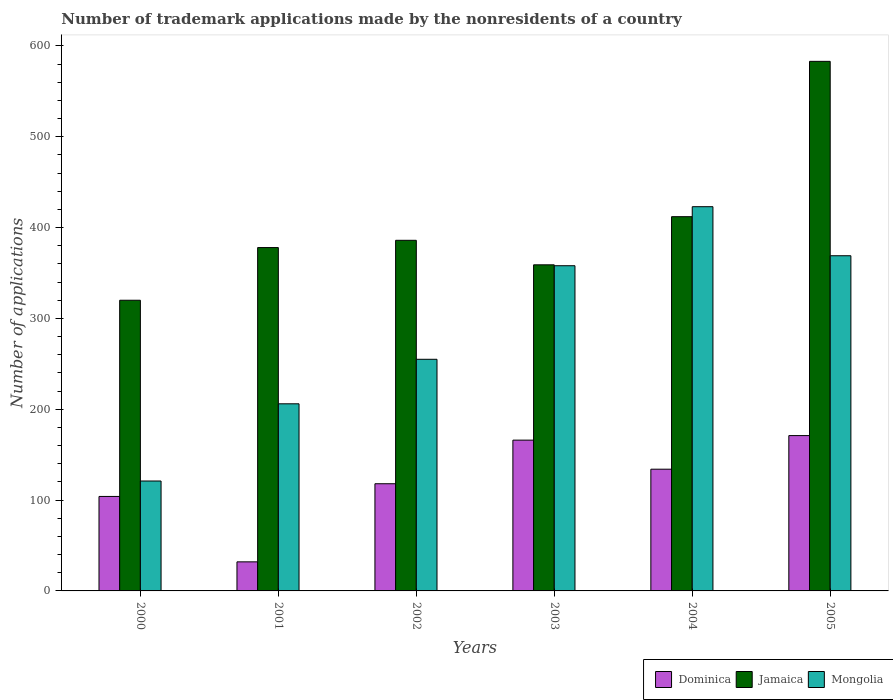How many different coloured bars are there?
Your answer should be very brief. 3. How many groups of bars are there?
Keep it short and to the point. 6. Are the number of bars per tick equal to the number of legend labels?
Your answer should be very brief. Yes. What is the label of the 2nd group of bars from the left?
Provide a short and direct response. 2001. In how many cases, is the number of bars for a given year not equal to the number of legend labels?
Ensure brevity in your answer.  0. Across all years, what is the maximum number of trademark applications made by the nonresidents in Dominica?
Give a very brief answer. 171. Across all years, what is the minimum number of trademark applications made by the nonresidents in Jamaica?
Offer a terse response. 320. In which year was the number of trademark applications made by the nonresidents in Mongolia maximum?
Offer a terse response. 2004. What is the total number of trademark applications made by the nonresidents in Mongolia in the graph?
Your answer should be compact. 1732. What is the difference between the number of trademark applications made by the nonresidents in Jamaica in 2003 and that in 2004?
Ensure brevity in your answer.  -53. What is the difference between the number of trademark applications made by the nonresidents in Jamaica in 2000 and the number of trademark applications made by the nonresidents in Mongolia in 2001?
Provide a succinct answer. 114. What is the average number of trademark applications made by the nonresidents in Jamaica per year?
Provide a succinct answer. 406.33. In the year 2002, what is the difference between the number of trademark applications made by the nonresidents in Dominica and number of trademark applications made by the nonresidents in Mongolia?
Your answer should be very brief. -137. What is the ratio of the number of trademark applications made by the nonresidents in Jamaica in 2002 to that in 2004?
Your response must be concise. 0.94. Is the difference between the number of trademark applications made by the nonresidents in Dominica in 2000 and 2004 greater than the difference between the number of trademark applications made by the nonresidents in Mongolia in 2000 and 2004?
Make the answer very short. Yes. What is the difference between the highest and the second highest number of trademark applications made by the nonresidents in Dominica?
Ensure brevity in your answer.  5. What is the difference between the highest and the lowest number of trademark applications made by the nonresidents in Mongolia?
Give a very brief answer. 302. Is the sum of the number of trademark applications made by the nonresidents in Jamaica in 2000 and 2003 greater than the maximum number of trademark applications made by the nonresidents in Dominica across all years?
Offer a very short reply. Yes. What does the 2nd bar from the left in 2005 represents?
Your response must be concise. Jamaica. What does the 3rd bar from the right in 2001 represents?
Provide a short and direct response. Dominica. Is it the case that in every year, the sum of the number of trademark applications made by the nonresidents in Jamaica and number of trademark applications made by the nonresidents in Dominica is greater than the number of trademark applications made by the nonresidents in Mongolia?
Your answer should be compact. Yes. How many bars are there?
Keep it short and to the point. 18. How many years are there in the graph?
Your answer should be compact. 6. What is the difference between two consecutive major ticks on the Y-axis?
Give a very brief answer. 100. Does the graph contain any zero values?
Your answer should be very brief. No. Does the graph contain grids?
Ensure brevity in your answer.  No. Where does the legend appear in the graph?
Offer a very short reply. Bottom right. How many legend labels are there?
Your response must be concise. 3. How are the legend labels stacked?
Keep it short and to the point. Horizontal. What is the title of the graph?
Your answer should be compact. Number of trademark applications made by the nonresidents of a country. What is the label or title of the Y-axis?
Offer a very short reply. Number of applications. What is the Number of applications of Dominica in 2000?
Provide a succinct answer. 104. What is the Number of applications of Jamaica in 2000?
Give a very brief answer. 320. What is the Number of applications of Mongolia in 2000?
Your answer should be very brief. 121. What is the Number of applications of Dominica in 2001?
Keep it short and to the point. 32. What is the Number of applications in Jamaica in 2001?
Give a very brief answer. 378. What is the Number of applications in Mongolia in 2001?
Ensure brevity in your answer.  206. What is the Number of applications in Dominica in 2002?
Provide a short and direct response. 118. What is the Number of applications in Jamaica in 2002?
Ensure brevity in your answer.  386. What is the Number of applications of Mongolia in 2002?
Ensure brevity in your answer.  255. What is the Number of applications in Dominica in 2003?
Offer a very short reply. 166. What is the Number of applications of Jamaica in 2003?
Provide a succinct answer. 359. What is the Number of applications in Mongolia in 2003?
Your response must be concise. 358. What is the Number of applications in Dominica in 2004?
Provide a short and direct response. 134. What is the Number of applications in Jamaica in 2004?
Your answer should be very brief. 412. What is the Number of applications of Mongolia in 2004?
Your answer should be very brief. 423. What is the Number of applications of Dominica in 2005?
Give a very brief answer. 171. What is the Number of applications of Jamaica in 2005?
Make the answer very short. 583. What is the Number of applications in Mongolia in 2005?
Keep it short and to the point. 369. Across all years, what is the maximum Number of applications in Dominica?
Give a very brief answer. 171. Across all years, what is the maximum Number of applications in Jamaica?
Provide a short and direct response. 583. Across all years, what is the maximum Number of applications of Mongolia?
Keep it short and to the point. 423. Across all years, what is the minimum Number of applications of Jamaica?
Ensure brevity in your answer.  320. Across all years, what is the minimum Number of applications in Mongolia?
Make the answer very short. 121. What is the total Number of applications in Dominica in the graph?
Provide a short and direct response. 725. What is the total Number of applications of Jamaica in the graph?
Offer a very short reply. 2438. What is the total Number of applications of Mongolia in the graph?
Keep it short and to the point. 1732. What is the difference between the Number of applications of Jamaica in 2000 and that in 2001?
Provide a short and direct response. -58. What is the difference between the Number of applications of Mongolia in 2000 and that in 2001?
Make the answer very short. -85. What is the difference between the Number of applications in Jamaica in 2000 and that in 2002?
Provide a succinct answer. -66. What is the difference between the Number of applications in Mongolia in 2000 and that in 2002?
Offer a terse response. -134. What is the difference between the Number of applications of Dominica in 2000 and that in 2003?
Ensure brevity in your answer.  -62. What is the difference between the Number of applications of Jamaica in 2000 and that in 2003?
Your response must be concise. -39. What is the difference between the Number of applications in Mongolia in 2000 and that in 2003?
Make the answer very short. -237. What is the difference between the Number of applications in Jamaica in 2000 and that in 2004?
Keep it short and to the point. -92. What is the difference between the Number of applications of Mongolia in 2000 and that in 2004?
Keep it short and to the point. -302. What is the difference between the Number of applications of Dominica in 2000 and that in 2005?
Ensure brevity in your answer.  -67. What is the difference between the Number of applications in Jamaica in 2000 and that in 2005?
Your answer should be very brief. -263. What is the difference between the Number of applications in Mongolia in 2000 and that in 2005?
Your answer should be very brief. -248. What is the difference between the Number of applications of Dominica in 2001 and that in 2002?
Provide a short and direct response. -86. What is the difference between the Number of applications of Jamaica in 2001 and that in 2002?
Offer a very short reply. -8. What is the difference between the Number of applications in Mongolia in 2001 and that in 2002?
Provide a short and direct response. -49. What is the difference between the Number of applications of Dominica in 2001 and that in 2003?
Provide a short and direct response. -134. What is the difference between the Number of applications in Mongolia in 2001 and that in 2003?
Offer a very short reply. -152. What is the difference between the Number of applications in Dominica in 2001 and that in 2004?
Provide a succinct answer. -102. What is the difference between the Number of applications in Jamaica in 2001 and that in 2004?
Provide a short and direct response. -34. What is the difference between the Number of applications in Mongolia in 2001 and that in 2004?
Your answer should be compact. -217. What is the difference between the Number of applications of Dominica in 2001 and that in 2005?
Make the answer very short. -139. What is the difference between the Number of applications in Jamaica in 2001 and that in 2005?
Ensure brevity in your answer.  -205. What is the difference between the Number of applications of Mongolia in 2001 and that in 2005?
Your answer should be very brief. -163. What is the difference between the Number of applications in Dominica in 2002 and that in 2003?
Give a very brief answer. -48. What is the difference between the Number of applications in Jamaica in 2002 and that in 2003?
Your response must be concise. 27. What is the difference between the Number of applications of Mongolia in 2002 and that in 2003?
Provide a succinct answer. -103. What is the difference between the Number of applications of Dominica in 2002 and that in 2004?
Give a very brief answer. -16. What is the difference between the Number of applications of Jamaica in 2002 and that in 2004?
Offer a terse response. -26. What is the difference between the Number of applications of Mongolia in 2002 and that in 2004?
Offer a terse response. -168. What is the difference between the Number of applications in Dominica in 2002 and that in 2005?
Your answer should be very brief. -53. What is the difference between the Number of applications in Jamaica in 2002 and that in 2005?
Keep it short and to the point. -197. What is the difference between the Number of applications of Mongolia in 2002 and that in 2005?
Ensure brevity in your answer.  -114. What is the difference between the Number of applications in Dominica in 2003 and that in 2004?
Your response must be concise. 32. What is the difference between the Number of applications of Jamaica in 2003 and that in 2004?
Your answer should be compact. -53. What is the difference between the Number of applications in Mongolia in 2003 and that in 2004?
Provide a short and direct response. -65. What is the difference between the Number of applications in Dominica in 2003 and that in 2005?
Your answer should be compact. -5. What is the difference between the Number of applications in Jamaica in 2003 and that in 2005?
Provide a succinct answer. -224. What is the difference between the Number of applications of Dominica in 2004 and that in 2005?
Your response must be concise. -37. What is the difference between the Number of applications of Jamaica in 2004 and that in 2005?
Keep it short and to the point. -171. What is the difference between the Number of applications of Dominica in 2000 and the Number of applications of Jamaica in 2001?
Give a very brief answer. -274. What is the difference between the Number of applications in Dominica in 2000 and the Number of applications in Mongolia in 2001?
Make the answer very short. -102. What is the difference between the Number of applications of Jamaica in 2000 and the Number of applications of Mongolia in 2001?
Make the answer very short. 114. What is the difference between the Number of applications of Dominica in 2000 and the Number of applications of Jamaica in 2002?
Provide a succinct answer. -282. What is the difference between the Number of applications in Dominica in 2000 and the Number of applications in Mongolia in 2002?
Offer a terse response. -151. What is the difference between the Number of applications of Jamaica in 2000 and the Number of applications of Mongolia in 2002?
Provide a short and direct response. 65. What is the difference between the Number of applications in Dominica in 2000 and the Number of applications in Jamaica in 2003?
Keep it short and to the point. -255. What is the difference between the Number of applications in Dominica in 2000 and the Number of applications in Mongolia in 2003?
Offer a terse response. -254. What is the difference between the Number of applications in Jamaica in 2000 and the Number of applications in Mongolia in 2003?
Your response must be concise. -38. What is the difference between the Number of applications of Dominica in 2000 and the Number of applications of Jamaica in 2004?
Give a very brief answer. -308. What is the difference between the Number of applications of Dominica in 2000 and the Number of applications of Mongolia in 2004?
Keep it short and to the point. -319. What is the difference between the Number of applications in Jamaica in 2000 and the Number of applications in Mongolia in 2004?
Your response must be concise. -103. What is the difference between the Number of applications in Dominica in 2000 and the Number of applications in Jamaica in 2005?
Offer a very short reply. -479. What is the difference between the Number of applications of Dominica in 2000 and the Number of applications of Mongolia in 2005?
Make the answer very short. -265. What is the difference between the Number of applications of Jamaica in 2000 and the Number of applications of Mongolia in 2005?
Offer a terse response. -49. What is the difference between the Number of applications of Dominica in 2001 and the Number of applications of Jamaica in 2002?
Give a very brief answer. -354. What is the difference between the Number of applications of Dominica in 2001 and the Number of applications of Mongolia in 2002?
Make the answer very short. -223. What is the difference between the Number of applications of Jamaica in 2001 and the Number of applications of Mongolia in 2002?
Your answer should be very brief. 123. What is the difference between the Number of applications in Dominica in 2001 and the Number of applications in Jamaica in 2003?
Ensure brevity in your answer.  -327. What is the difference between the Number of applications in Dominica in 2001 and the Number of applications in Mongolia in 2003?
Your answer should be compact. -326. What is the difference between the Number of applications of Dominica in 2001 and the Number of applications of Jamaica in 2004?
Your answer should be compact. -380. What is the difference between the Number of applications of Dominica in 2001 and the Number of applications of Mongolia in 2004?
Ensure brevity in your answer.  -391. What is the difference between the Number of applications of Jamaica in 2001 and the Number of applications of Mongolia in 2004?
Your answer should be compact. -45. What is the difference between the Number of applications in Dominica in 2001 and the Number of applications in Jamaica in 2005?
Offer a terse response. -551. What is the difference between the Number of applications of Dominica in 2001 and the Number of applications of Mongolia in 2005?
Provide a short and direct response. -337. What is the difference between the Number of applications of Dominica in 2002 and the Number of applications of Jamaica in 2003?
Give a very brief answer. -241. What is the difference between the Number of applications of Dominica in 2002 and the Number of applications of Mongolia in 2003?
Provide a succinct answer. -240. What is the difference between the Number of applications in Dominica in 2002 and the Number of applications in Jamaica in 2004?
Offer a very short reply. -294. What is the difference between the Number of applications of Dominica in 2002 and the Number of applications of Mongolia in 2004?
Your response must be concise. -305. What is the difference between the Number of applications in Jamaica in 2002 and the Number of applications in Mongolia in 2004?
Make the answer very short. -37. What is the difference between the Number of applications of Dominica in 2002 and the Number of applications of Jamaica in 2005?
Make the answer very short. -465. What is the difference between the Number of applications in Dominica in 2002 and the Number of applications in Mongolia in 2005?
Give a very brief answer. -251. What is the difference between the Number of applications of Jamaica in 2002 and the Number of applications of Mongolia in 2005?
Provide a short and direct response. 17. What is the difference between the Number of applications of Dominica in 2003 and the Number of applications of Jamaica in 2004?
Offer a terse response. -246. What is the difference between the Number of applications of Dominica in 2003 and the Number of applications of Mongolia in 2004?
Ensure brevity in your answer.  -257. What is the difference between the Number of applications of Jamaica in 2003 and the Number of applications of Mongolia in 2004?
Your response must be concise. -64. What is the difference between the Number of applications of Dominica in 2003 and the Number of applications of Jamaica in 2005?
Offer a very short reply. -417. What is the difference between the Number of applications of Dominica in 2003 and the Number of applications of Mongolia in 2005?
Ensure brevity in your answer.  -203. What is the difference between the Number of applications in Jamaica in 2003 and the Number of applications in Mongolia in 2005?
Ensure brevity in your answer.  -10. What is the difference between the Number of applications of Dominica in 2004 and the Number of applications of Jamaica in 2005?
Make the answer very short. -449. What is the difference between the Number of applications in Dominica in 2004 and the Number of applications in Mongolia in 2005?
Ensure brevity in your answer.  -235. What is the average Number of applications in Dominica per year?
Make the answer very short. 120.83. What is the average Number of applications of Jamaica per year?
Give a very brief answer. 406.33. What is the average Number of applications of Mongolia per year?
Offer a very short reply. 288.67. In the year 2000, what is the difference between the Number of applications of Dominica and Number of applications of Jamaica?
Your response must be concise. -216. In the year 2000, what is the difference between the Number of applications of Dominica and Number of applications of Mongolia?
Offer a very short reply. -17. In the year 2000, what is the difference between the Number of applications of Jamaica and Number of applications of Mongolia?
Your answer should be very brief. 199. In the year 2001, what is the difference between the Number of applications of Dominica and Number of applications of Jamaica?
Keep it short and to the point. -346. In the year 2001, what is the difference between the Number of applications of Dominica and Number of applications of Mongolia?
Provide a short and direct response. -174. In the year 2001, what is the difference between the Number of applications of Jamaica and Number of applications of Mongolia?
Keep it short and to the point. 172. In the year 2002, what is the difference between the Number of applications of Dominica and Number of applications of Jamaica?
Your answer should be very brief. -268. In the year 2002, what is the difference between the Number of applications in Dominica and Number of applications in Mongolia?
Provide a succinct answer. -137. In the year 2002, what is the difference between the Number of applications of Jamaica and Number of applications of Mongolia?
Make the answer very short. 131. In the year 2003, what is the difference between the Number of applications in Dominica and Number of applications in Jamaica?
Give a very brief answer. -193. In the year 2003, what is the difference between the Number of applications in Dominica and Number of applications in Mongolia?
Offer a very short reply. -192. In the year 2003, what is the difference between the Number of applications in Jamaica and Number of applications in Mongolia?
Provide a succinct answer. 1. In the year 2004, what is the difference between the Number of applications in Dominica and Number of applications in Jamaica?
Your answer should be very brief. -278. In the year 2004, what is the difference between the Number of applications of Dominica and Number of applications of Mongolia?
Give a very brief answer. -289. In the year 2004, what is the difference between the Number of applications of Jamaica and Number of applications of Mongolia?
Give a very brief answer. -11. In the year 2005, what is the difference between the Number of applications in Dominica and Number of applications in Jamaica?
Keep it short and to the point. -412. In the year 2005, what is the difference between the Number of applications of Dominica and Number of applications of Mongolia?
Your answer should be very brief. -198. In the year 2005, what is the difference between the Number of applications in Jamaica and Number of applications in Mongolia?
Make the answer very short. 214. What is the ratio of the Number of applications of Dominica in 2000 to that in 2001?
Provide a succinct answer. 3.25. What is the ratio of the Number of applications in Jamaica in 2000 to that in 2001?
Your answer should be very brief. 0.85. What is the ratio of the Number of applications of Mongolia in 2000 to that in 2001?
Your response must be concise. 0.59. What is the ratio of the Number of applications in Dominica in 2000 to that in 2002?
Make the answer very short. 0.88. What is the ratio of the Number of applications of Jamaica in 2000 to that in 2002?
Keep it short and to the point. 0.83. What is the ratio of the Number of applications of Mongolia in 2000 to that in 2002?
Provide a succinct answer. 0.47. What is the ratio of the Number of applications in Dominica in 2000 to that in 2003?
Keep it short and to the point. 0.63. What is the ratio of the Number of applications of Jamaica in 2000 to that in 2003?
Offer a very short reply. 0.89. What is the ratio of the Number of applications of Mongolia in 2000 to that in 2003?
Give a very brief answer. 0.34. What is the ratio of the Number of applications of Dominica in 2000 to that in 2004?
Provide a succinct answer. 0.78. What is the ratio of the Number of applications in Jamaica in 2000 to that in 2004?
Ensure brevity in your answer.  0.78. What is the ratio of the Number of applications of Mongolia in 2000 to that in 2004?
Your response must be concise. 0.29. What is the ratio of the Number of applications of Dominica in 2000 to that in 2005?
Your answer should be very brief. 0.61. What is the ratio of the Number of applications in Jamaica in 2000 to that in 2005?
Your response must be concise. 0.55. What is the ratio of the Number of applications of Mongolia in 2000 to that in 2005?
Ensure brevity in your answer.  0.33. What is the ratio of the Number of applications of Dominica in 2001 to that in 2002?
Provide a short and direct response. 0.27. What is the ratio of the Number of applications in Jamaica in 2001 to that in 2002?
Your answer should be very brief. 0.98. What is the ratio of the Number of applications of Mongolia in 2001 to that in 2002?
Your response must be concise. 0.81. What is the ratio of the Number of applications in Dominica in 2001 to that in 2003?
Make the answer very short. 0.19. What is the ratio of the Number of applications in Jamaica in 2001 to that in 2003?
Keep it short and to the point. 1.05. What is the ratio of the Number of applications of Mongolia in 2001 to that in 2003?
Give a very brief answer. 0.58. What is the ratio of the Number of applications in Dominica in 2001 to that in 2004?
Ensure brevity in your answer.  0.24. What is the ratio of the Number of applications in Jamaica in 2001 to that in 2004?
Your answer should be very brief. 0.92. What is the ratio of the Number of applications of Mongolia in 2001 to that in 2004?
Make the answer very short. 0.49. What is the ratio of the Number of applications of Dominica in 2001 to that in 2005?
Keep it short and to the point. 0.19. What is the ratio of the Number of applications of Jamaica in 2001 to that in 2005?
Provide a succinct answer. 0.65. What is the ratio of the Number of applications of Mongolia in 2001 to that in 2005?
Keep it short and to the point. 0.56. What is the ratio of the Number of applications in Dominica in 2002 to that in 2003?
Your answer should be very brief. 0.71. What is the ratio of the Number of applications in Jamaica in 2002 to that in 2003?
Give a very brief answer. 1.08. What is the ratio of the Number of applications of Mongolia in 2002 to that in 2003?
Provide a short and direct response. 0.71. What is the ratio of the Number of applications in Dominica in 2002 to that in 2004?
Your answer should be compact. 0.88. What is the ratio of the Number of applications of Jamaica in 2002 to that in 2004?
Make the answer very short. 0.94. What is the ratio of the Number of applications of Mongolia in 2002 to that in 2004?
Your answer should be very brief. 0.6. What is the ratio of the Number of applications of Dominica in 2002 to that in 2005?
Give a very brief answer. 0.69. What is the ratio of the Number of applications in Jamaica in 2002 to that in 2005?
Give a very brief answer. 0.66. What is the ratio of the Number of applications in Mongolia in 2002 to that in 2005?
Your answer should be compact. 0.69. What is the ratio of the Number of applications in Dominica in 2003 to that in 2004?
Ensure brevity in your answer.  1.24. What is the ratio of the Number of applications of Jamaica in 2003 to that in 2004?
Your answer should be very brief. 0.87. What is the ratio of the Number of applications of Mongolia in 2003 to that in 2004?
Your answer should be compact. 0.85. What is the ratio of the Number of applications in Dominica in 2003 to that in 2005?
Your answer should be compact. 0.97. What is the ratio of the Number of applications in Jamaica in 2003 to that in 2005?
Your answer should be compact. 0.62. What is the ratio of the Number of applications of Mongolia in 2003 to that in 2005?
Keep it short and to the point. 0.97. What is the ratio of the Number of applications in Dominica in 2004 to that in 2005?
Ensure brevity in your answer.  0.78. What is the ratio of the Number of applications in Jamaica in 2004 to that in 2005?
Your answer should be very brief. 0.71. What is the ratio of the Number of applications of Mongolia in 2004 to that in 2005?
Your answer should be compact. 1.15. What is the difference between the highest and the second highest Number of applications in Jamaica?
Provide a short and direct response. 171. What is the difference between the highest and the lowest Number of applications of Dominica?
Your response must be concise. 139. What is the difference between the highest and the lowest Number of applications in Jamaica?
Make the answer very short. 263. What is the difference between the highest and the lowest Number of applications of Mongolia?
Offer a terse response. 302. 